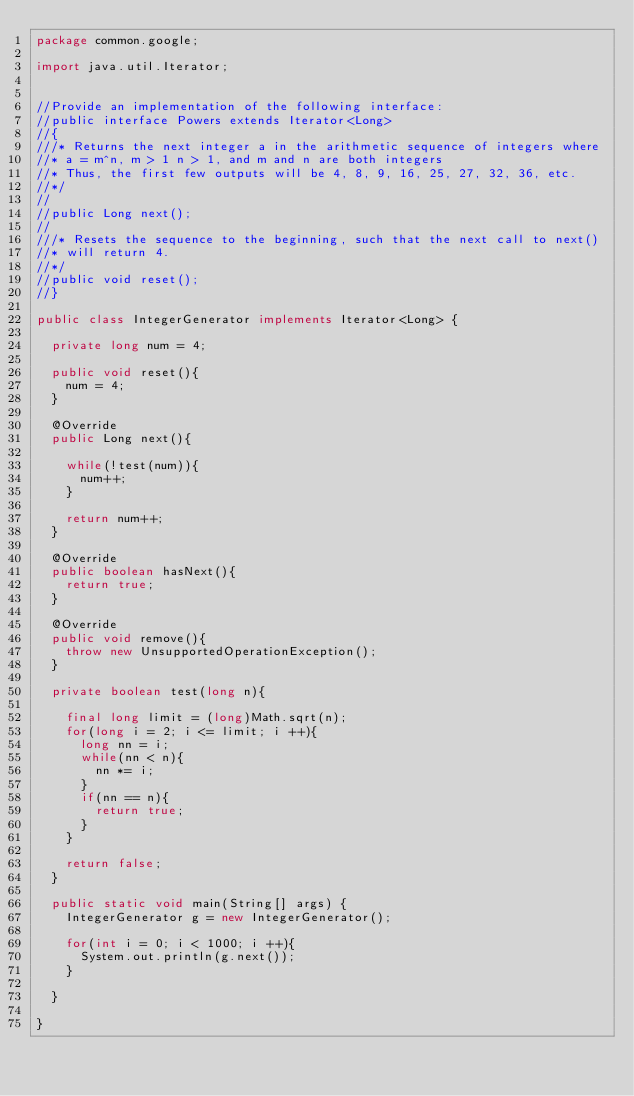Convert code to text. <code><loc_0><loc_0><loc_500><loc_500><_Java_>package common.google;

import java.util.Iterator;


//Provide an implementation of the following interface:
//public interface Powers extends Iterator<Long>
//{
///* Returns the next integer a in the arithmetic sequence of integers where
//* a = m^n, m > 1 n > 1, and m and n are both integers
//* Thus, the first few outputs will be 4, 8, 9, 16, 25, 27, 32, 36, etc.
//*/
//
//public Long next();
//
///* Resets the sequence to the beginning, such that the next call to next()
//* will return 4.
//*/
//public void reset();
//}

public class IntegerGenerator implements Iterator<Long> {
	
	private long num = 4;
	
	public void reset(){
		num = 4;
	}

	@Override
	public Long next(){

		while(!test(num)){
			num++;
		}
		
		return num++;
	}
	
	@Override
	public boolean hasNext(){
		return true;
	}
	
	@Override
	public void remove(){
		throw new UnsupportedOperationException();
	}

	private boolean test(long n){
		
		final long limit = (long)Math.sqrt(n);
		for(long i = 2; i <= limit; i ++){
			long nn = i;
			while(nn < n){
				nn *= i;
			}
			if(nn == n){
				return true;
			}
		}
		
		return false;
	}
	
	public static void main(String[] args) {
		IntegerGenerator g = new IntegerGenerator();
		
		for(int i = 0; i < 1000; i ++){
			System.out.println(g.next());
		}

	}

}
</code> 